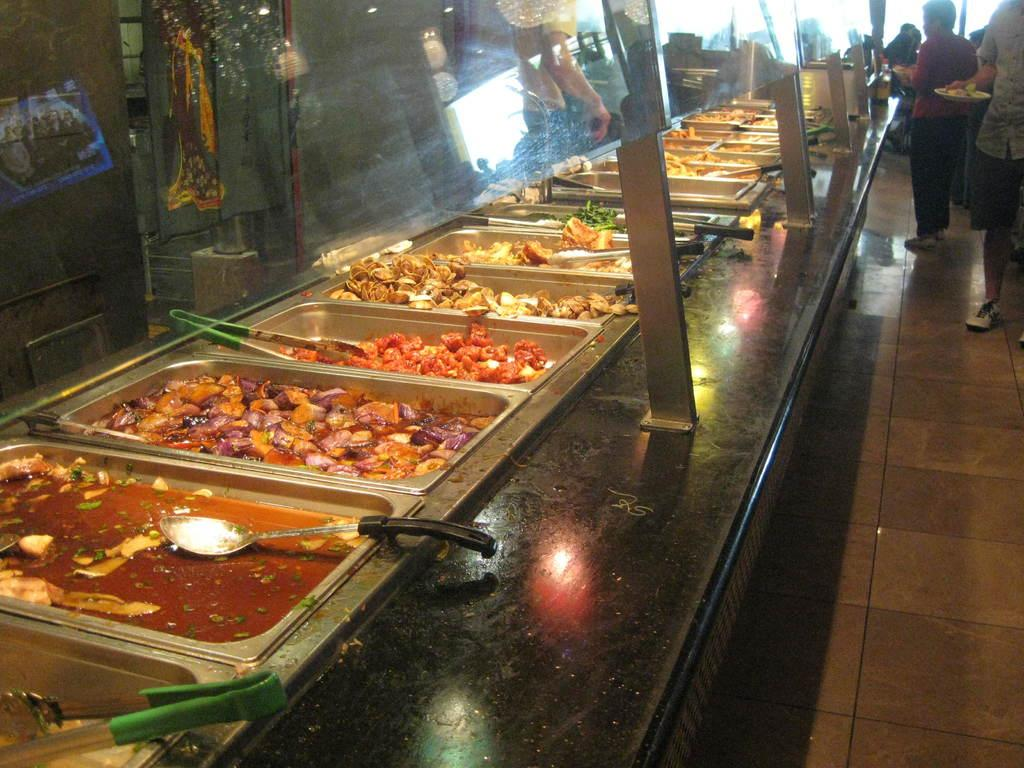What is placed in the container in the image? There are eatables placed in a container in the image. Where is the container located? The container is on a table in the image. Are there any people visible in the image? Yes, there are persons standing in the right corner of the image. What type of stamp can be seen on the container in the image? There is no stamp visible on the container in the image. 